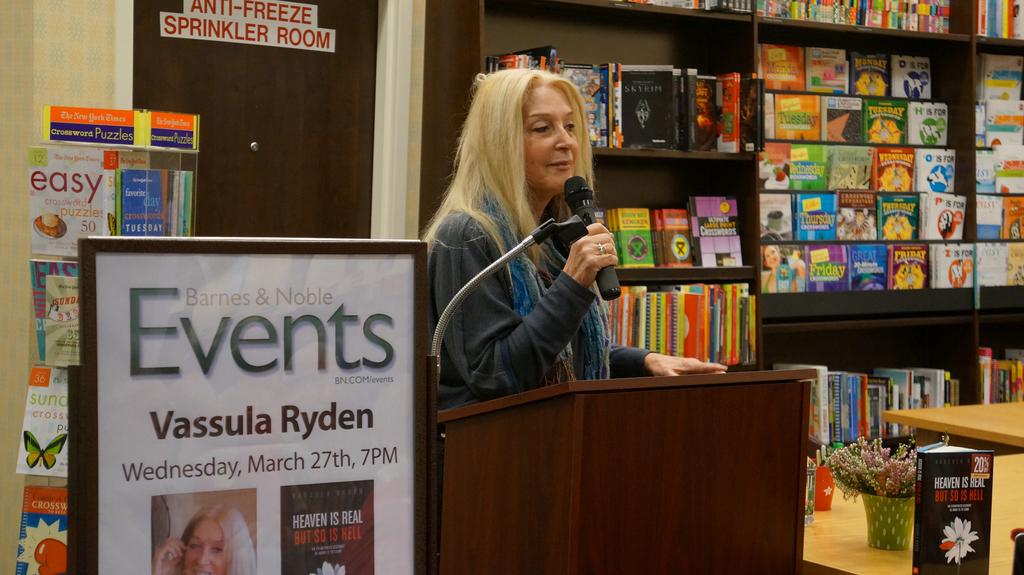Where is this event taking place?
Offer a terse response. Barnes & noble. What is the woman's name printed on the large sign nearest to the camera?
Make the answer very short. Vassula ryden. 